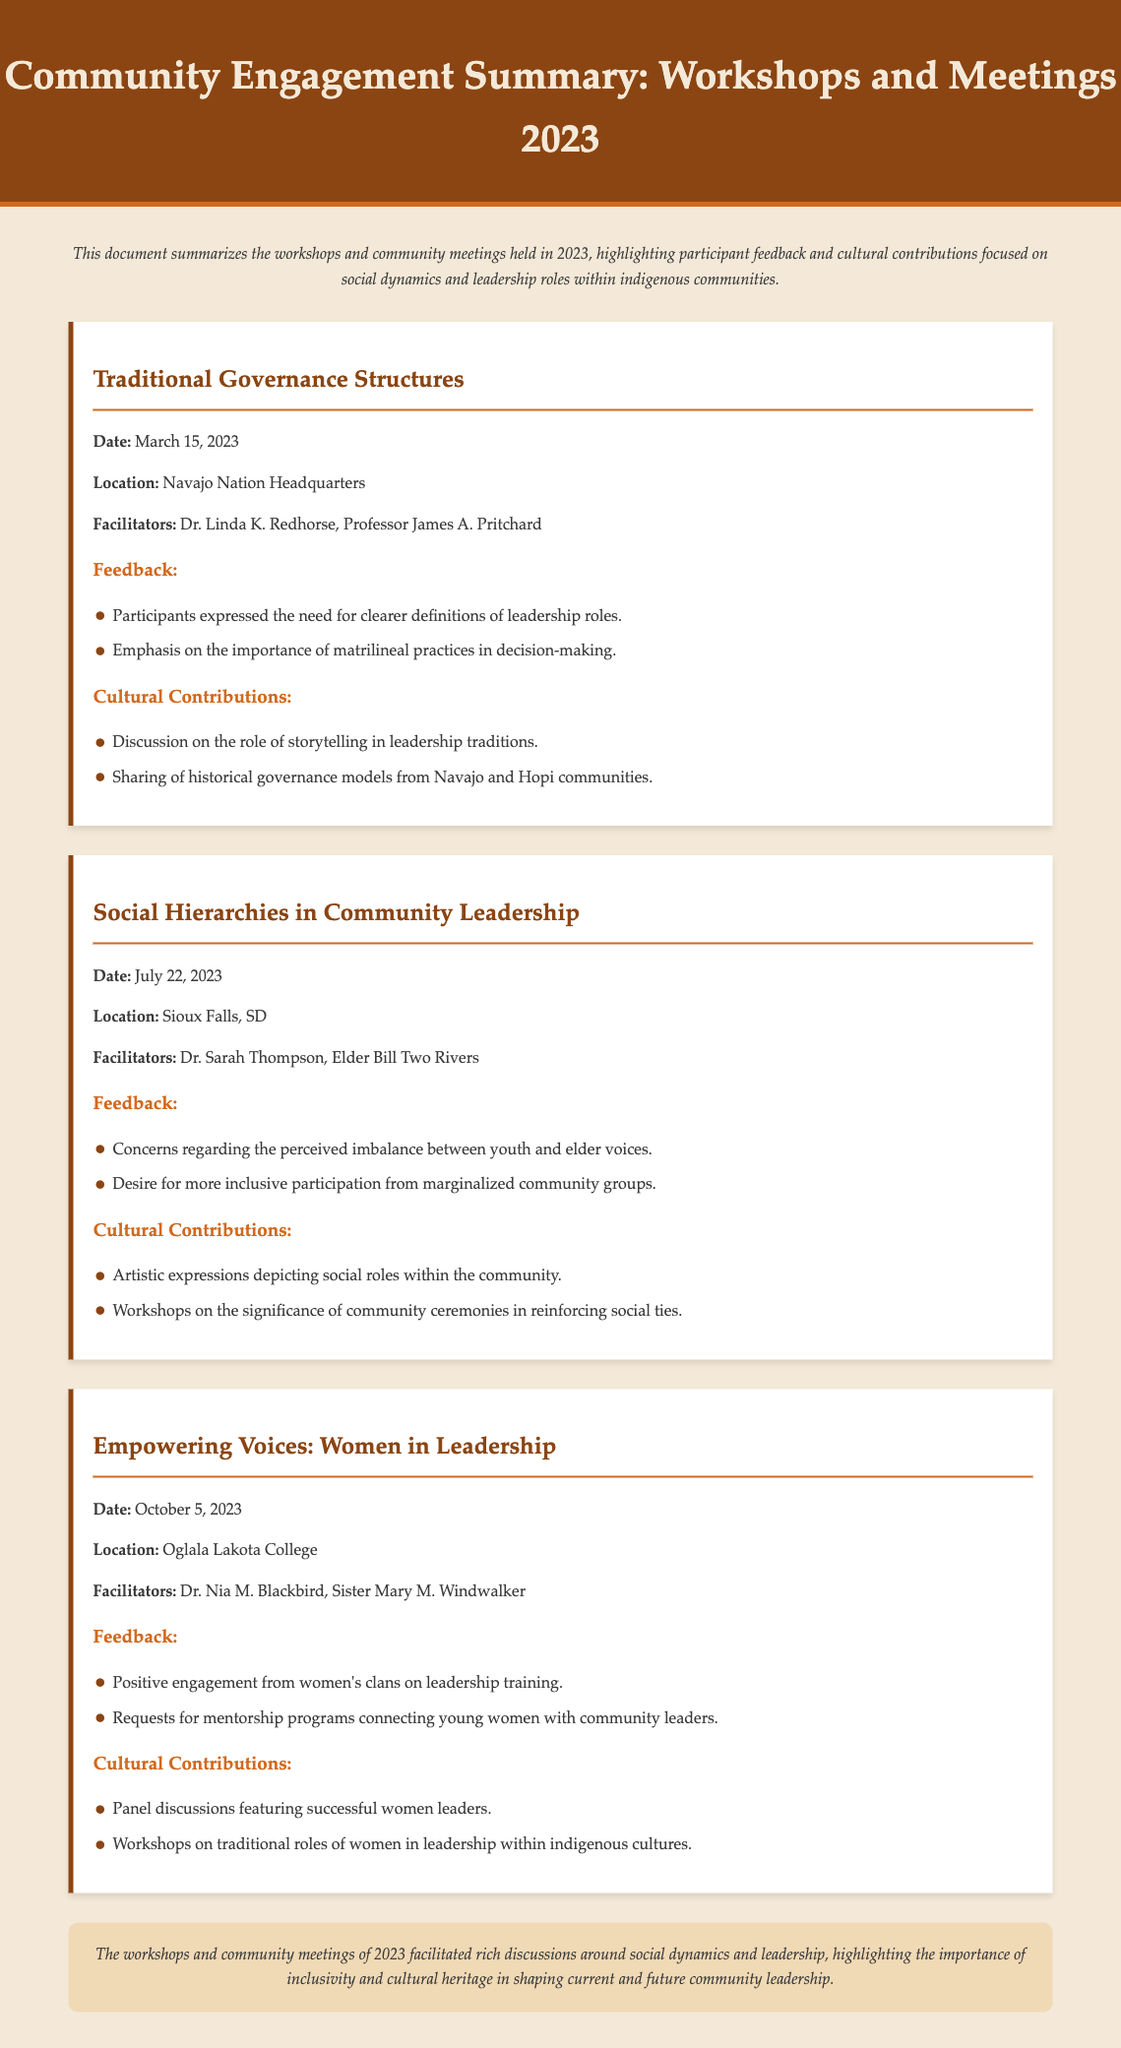What is the title of the document? The title is provided in the header of the document, which summarizes community engagement activities for the year 2023.
Answer: Community Engagement Summary: Workshops and Meetings 2023 What was the date of the workshop on Traditional Governance Structures? This information is located under the respective workshop section detailing when it took place.
Answer: March 15, 2023 Who facilitated the workshop titled Empowering Voices: Women in Leadership? The facilitators' names are mentioned in the workshop section, indicating who led the discussions.
Answer: Dr. Nia M. Blackbird, Sister Mary M. Windwalker What location hosted the Social Hierarchies in Community Leadership workshop? The specific location is listed in the workshop details, indicating where the event was held.
Answer: Sioux Falls, SD What main concern was raised during the workshop on Social Hierarchies in Community Leadership? The feedback section of the workshop lists main concerns expressed by participants.
Answer: Imbalance between youth and elder voices What type of discussions were included in the Empowering Voices workshop? The cultural contributions section outlines what specific activities and dialogues took place during the workshop.
Answer: Panel discussions featuring successful women leaders How many workshops are summarized in the document? The number of distinct workshops is determined by counting the separate sections laid out in the document.
Answer: Three What theme did the Traditional Governance Structures workshop emphasize? The feedback section reflects the central topics or values highlighted during the discussions of the workshop.
Answer: Importance of matrilineal practices in decision-making What is the conclusion regarding the workshops held in 2023? The concluding remarks summarize the overall impact and takeaways from the events described in the document.
Answer: Importance of inclusivity and cultural heritage in shaping current and future community leadership 